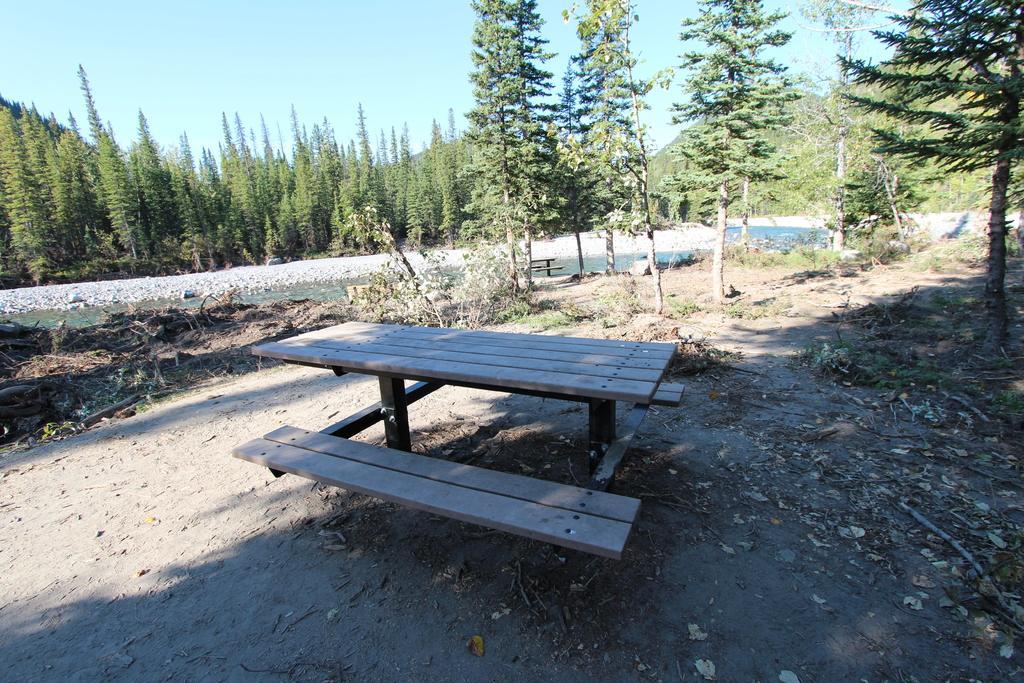Describe this image in one or two sentences. This is an outside view. Here I can see a table on the ground. There are many dry leaves and sticks on the ground. In the background there are many trees and also I can see a lake. At the top of the image I can see the sky. 